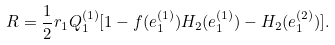<formula> <loc_0><loc_0><loc_500><loc_500>R = \frac { 1 } { 2 } r _ { 1 } Q _ { 1 } ^ { ( 1 ) } [ 1 - f ( e _ { 1 } ^ { ( 1 ) } ) H _ { 2 } ( e _ { 1 } ^ { ( 1 ) } ) - H _ { 2 } ( e _ { 1 } ^ { ( 2 ) } ) ] .</formula> 